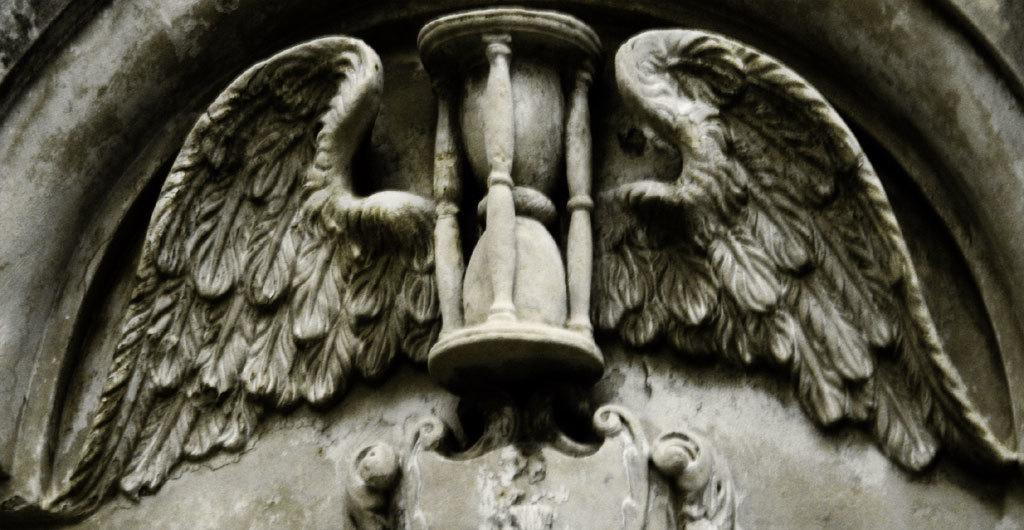What is the main subject of the image? There is a sculpture in the image. What type of toys can be seen in the image? There are no toys present in the image; it features a sculpture. Is there a rat interacting with the sculpture in the image? There is no rat present in the image; it only features a sculpture. 